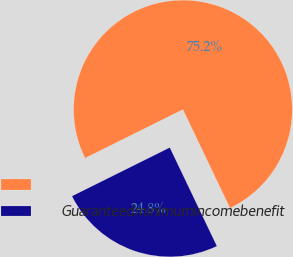<chart> <loc_0><loc_0><loc_500><loc_500><pie_chart><ecel><fcel>Guaranteedminimumincomebenefit<nl><fcel>75.25%<fcel>24.75%<nl></chart> 